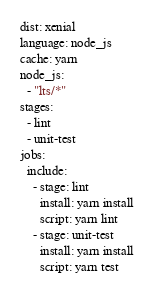<code> <loc_0><loc_0><loc_500><loc_500><_YAML_>dist: xenial
language: node_js
cache: yarn
node_js:
  - "lts/*"
stages:
  - lint
  - unit-test
jobs:
  include:
    - stage: lint
      install: yarn install
      script: yarn lint
    - stage: unit-test
      install: yarn install
      script: yarn test
</code> 